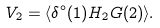Convert formula to latex. <formula><loc_0><loc_0><loc_500><loc_500>V _ { 2 } = \langle \delta ^ { \circ } ( 1 ) H _ { 2 } G ( 2 ) \rangle .</formula> 